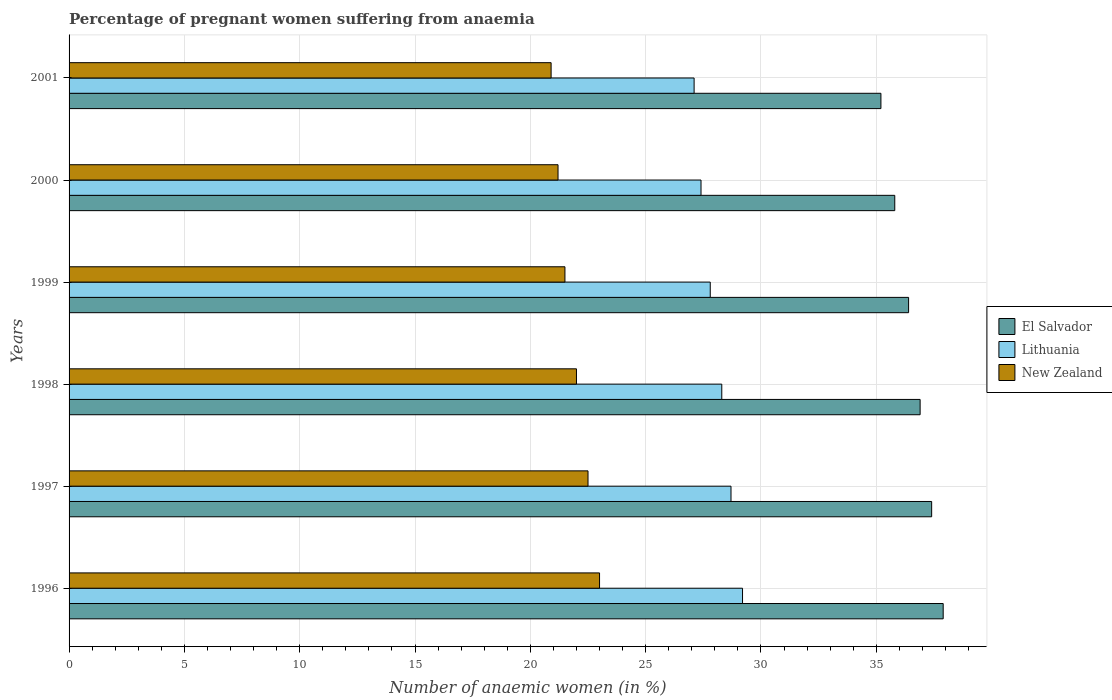How many different coloured bars are there?
Make the answer very short. 3. How many groups of bars are there?
Offer a terse response. 6. How many bars are there on the 1st tick from the top?
Your response must be concise. 3. How many bars are there on the 5th tick from the bottom?
Give a very brief answer. 3. In how many cases, is the number of bars for a given year not equal to the number of legend labels?
Offer a terse response. 0. What is the number of anaemic women in El Salvador in 1998?
Offer a terse response. 36.9. Across all years, what is the maximum number of anaemic women in Lithuania?
Offer a terse response. 29.2. Across all years, what is the minimum number of anaemic women in Lithuania?
Provide a succinct answer. 27.1. In which year was the number of anaemic women in El Salvador minimum?
Ensure brevity in your answer.  2001. What is the total number of anaemic women in New Zealand in the graph?
Your answer should be very brief. 131.1. What is the difference between the number of anaemic women in Lithuania in 1996 and that in 2001?
Give a very brief answer. 2.1. What is the difference between the number of anaemic women in Lithuania in 1996 and the number of anaemic women in New Zealand in 2000?
Provide a succinct answer. 8. What is the average number of anaemic women in New Zealand per year?
Provide a succinct answer. 21.85. In the year 1998, what is the difference between the number of anaemic women in El Salvador and number of anaemic women in Lithuania?
Make the answer very short. 8.6. In how many years, is the number of anaemic women in El Salvador greater than 37 %?
Ensure brevity in your answer.  2. What is the ratio of the number of anaemic women in El Salvador in 1996 to that in 2001?
Provide a succinct answer. 1.08. What is the difference between the highest and the lowest number of anaemic women in New Zealand?
Your response must be concise. 2.1. Is the sum of the number of anaemic women in New Zealand in 2000 and 2001 greater than the maximum number of anaemic women in El Salvador across all years?
Offer a terse response. Yes. What does the 3rd bar from the top in 1999 represents?
Ensure brevity in your answer.  El Salvador. What does the 1st bar from the bottom in 2001 represents?
Your answer should be compact. El Salvador. How many bars are there?
Give a very brief answer. 18. Are all the bars in the graph horizontal?
Your response must be concise. Yes. Are the values on the major ticks of X-axis written in scientific E-notation?
Make the answer very short. No. Does the graph contain any zero values?
Your answer should be compact. No. Does the graph contain grids?
Offer a very short reply. Yes. How are the legend labels stacked?
Provide a short and direct response. Vertical. What is the title of the graph?
Provide a succinct answer. Percentage of pregnant women suffering from anaemia. What is the label or title of the X-axis?
Your answer should be very brief. Number of anaemic women (in %). What is the Number of anaemic women (in %) in El Salvador in 1996?
Provide a succinct answer. 37.9. What is the Number of anaemic women (in %) of Lithuania in 1996?
Keep it short and to the point. 29.2. What is the Number of anaemic women (in %) of El Salvador in 1997?
Ensure brevity in your answer.  37.4. What is the Number of anaemic women (in %) in Lithuania in 1997?
Ensure brevity in your answer.  28.7. What is the Number of anaemic women (in %) in El Salvador in 1998?
Your answer should be very brief. 36.9. What is the Number of anaemic women (in %) of Lithuania in 1998?
Keep it short and to the point. 28.3. What is the Number of anaemic women (in %) in El Salvador in 1999?
Make the answer very short. 36.4. What is the Number of anaemic women (in %) of Lithuania in 1999?
Keep it short and to the point. 27.8. What is the Number of anaemic women (in %) of El Salvador in 2000?
Keep it short and to the point. 35.8. What is the Number of anaemic women (in %) of Lithuania in 2000?
Give a very brief answer. 27.4. What is the Number of anaemic women (in %) of New Zealand in 2000?
Provide a short and direct response. 21.2. What is the Number of anaemic women (in %) of El Salvador in 2001?
Give a very brief answer. 35.2. What is the Number of anaemic women (in %) of Lithuania in 2001?
Offer a very short reply. 27.1. What is the Number of anaemic women (in %) in New Zealand in 2001?
Provide a short and direct response. 20.9. Across all years, what is the maximum Number of anaemic women (in %) in El Salvador?
Your answer should be compact. 37.9. Across all years, what is the maximum Number of anaemic women (in %) in Lithuania?
Your response must be concise. 29.2. Across all years, what is the maximum Number of anaemic women (in %) in New Zealand?
Provide a short and direct response. 23. Across all years, what is the minimum Number of anaemic women (in %) of El Salvador?
Give a very brief answer. 35.2. Across all years, what is the minimum Number of anaemic women (in %) in Lithuania?
Ensure brevity in your answer.  27.1. Across all years, what is the minimum Number of anaemic women (in %) of New Zealand?
Ensure brevity in your answer.  20.9. What is the total Number of anaemic women (in %) of El Salvador in the graph?
Keep it short and to the point. 219.6. What is the total Number of anaemic women (in %) in Lithuania in the graph?
Provide a succinct answer. 168.5. What is the total Number of anaemic women (in %) of New Zealand in the graph?
Keep it short and to the point. 131.1. What is the difference between the Number of anaemic women (in %) in Lithuania in 1996 and that in 1997?
Make the answer very short. 0.5. What is the difference between the Number of anaemic women (in %) in New Zealand in 1996 and that in 1997?
Keep it short and to the point. 0.5. What is the difference between the Number of anaemic women (in %) of Lithuania in 1996 and that in 1998?
Ensure brevity in your answer.  0.9. What is the difference between the Number of anaemic women (in %) in New Zealand in 1996 and that in 1998?
Make the answer very short. 1. What is the difference between the Number of anaemic women (in %) of New Zealand in 1996 and that in 1999?
Ensure brevity in your answer.  1.5. What is the difference between the Number of anaemic women (in %) in New Zealand in 1996 and that in 2000?
Offer a very short reply. 1.8. What is the difference between the Number of anaemic women (in %) of Lithuania in 1996 and that in 2001?
Your answer should be very brief. 2.1. What is the difference between the Number of anaemic women (in %) in New Zealand in 1996 and that in 2001?
Offer a very short reply. 2.1. What is the difference between the Number of anaemic women (in %) of El Salvador in 1997 and that in 1998?
Provide a short and direct response. 0.5. What is the difference between the Number of anaemic women (in %) of New Zealand in 1997 and that in 1998?
Ensure brevity in your answer.  0.5. What is the difference between the Number of anaemic women (in %) of El Salvador in 1997 and that in 1999?
Provide a succinct answer. 1. What is the difference between the Number of anaemic women (in %) in El Salvador in 1997 and that in 2000?
Your answer should be compact. 1.6. What is the difference between the Number of anaemic women (in %) in New Zealand in 1997 and that in 2000?
Make the answer very short. 1.3. What is the difference between the Number of anaemic women (in %) in Lithuania in 1997 and that in 2001?
Ensure brevity in your answer.  1.6. What is the difference between the Number of anaemic women (in %) in New Zealand in 1997 and that in 2001?
Your response must be concise. 1.6. What is the difference between the Number of anaemic women (in %) in El Salvador in 1998 and that in 2000?
Make the answer very short. 1.1. What is the difference between the Number of anaemic women (in %) of New Zealand in 1998 and that in 2001?
Your answer should be very brief. 1.1. What is the difference between the Number of anaemic women (in %) in El Salvador in 1999 and that in 2000?
Your answer should be very brief. 0.6. What is the difference between the Number of anaemic women (in %) in Lithuania in 1999 and that in 2000?
Your response must be concise. 0.4. What is the difference between the Number of anaemic women (in %) of El Salvador in 1999 and that in 2001?
Offer a very short reply. 1.2. What is the difference between the Number of anaemic women (in %) in Lithuania in 1999 and that in 2001?
Make the answer very short. 0.7. What is the difference between the Number of anaemic women (in %) of New Zealand in 1999 and that in 2001?
Your answer should be very brief. 0.6. What is the difference between the Number of anaemic women (in %) in El Salvador in 1996 and the Number of anaemic women (in %) in Lithuania in 1997?
Ensure brevity in your answer.  9.2. What is the difference between the Number of anaemic women (in %) of El Salvador in 1996 and the Number of anaemic women (in %) of New Zealand in 1997?
Provide a short and direct response. 15.4. What is the difference between the Number of anaemic women (in %) in El Salvador in 1996 and the Number of anaemic women (in %) in Lithuania in 1998?
Offer a very short reply. 9.6. What is the difference between the Number of anaemic women (in %) of Lithuania in 1996 and the Number of anaemic women (in %) of New Zealand in 1998?
Ensure brevity in your answer.  7.2. What is the difference between the Number of anaemic women (in %) in El Salvador in 1996 and the Number of anaemic women (in %) in New Zealand in 2000?
Make the answer very short. 16.7. What is the difference between the Number of anaemic women (in %) of El Salvador in 1996 and the Number of anaemic women (in %) of Lithuania in 2001?
Your response must be concise. 10.8. What is the difference between the Number of anaemic women (in %) in Lithuania in 1996 and the Number of anaemic women (in %) in New Zealand in 2001?
Offer a terse response. 8.3. What is the difference between the Number of anaemic women (in %) in El Salvador in 1997 and the Number of anaemic women (in %) in New Zealand in 1999?
Your response must be concise. 15.9. What is the difference between the Number of anaemic women (in %) in Lithuania in 1997 and the Number of anaemic women (in %) in New Zealand in 2000?
Provide a short and direct response. 7.5. What is the difference between the Number of anaemic women (in %) in El Salvador in 1997 and the Number of anaemic women (in %) in Lithuania in 2001?
Make the answer very short. 10.3. What is the difference between the Number of anaemic women (in %) in El Salvador in 1997 and the Number of anaemic women (in %) in New Zealand in 2001?
Your answer should be compact. 16.5. What is the difference between the Number of anaemic women (in %) in El Salvador in 1998 and the Number of anaemic women (in %) in Lithuania in 2000?
Your answer should be very brief. 9.5. What is the difference between the Number of anaemic women (in %) in El Salvador in 1998 and the Number of anaemic women (in %) in New Zealand in 2000?
Give a very brief answer. 15.7. What is the difference between the Number of anaemic women (in %) in Lithuania in 1998 and the Number of anaemic women (in %) in New Zealand in 2000?
Provide a succinct answer. 7.1. What is the difference between the Number of anaemic women (in %) in Lithuania in 1999 and the Number of anaemic women (in %) in New Zealand in 2000?
Your response must be concise. 6.6. What is the difference between the Number of anaemic women (in %) in El Salvador in 1999 and the Number of anaemic women (in %) in New Zealand in 2001?
Provide a short and direct response. 15.5. What is the difference between the Number of anaemic women (in %) in El Salvador in 2000 and the Number of anaemic women (in %) in Lithuania in 2001?
Give a very brief answer. 8.7. What is the average Number of anaemic women (in %) of El Salvador per year?
Your response must be concise. 36.6. What is the average Number of anaemic women (in %) in Lithuania per year?
Your answer should be compact. 28.08. What is the average Number of anaemic women (in %) of New Zealand per year?
Make the answer very short. 21.85. In the year 1996, what is the difference between the Number of anaemic women (in %) of El Salvador and Number of anaemic women (in %) of New Zealand?
Ensure brevity in your answer.  14.9. In the year 1996, what is the difference between the Number of anaemic women (in %) of Lithuania and Number of anaemic women (in %) of New Zealand?
Provide a short and direct response. 6.2. In the year 1997, what is the difference between the Number of anaemic women (in %) in El Salvador and Number of anaemic women (in %) in Lithuania?
Ensure brevity in your answer.  8.7. In the year 1998, what is the difference between the Number of anaemic women (in %) in El Salvador and Number of anaemic women (in %) in New Zealand?
Provide a succinct answer. 14.9. In the year 1998, what is the difference between the Number of anaemic women (in %) of Lithuania and Number of anaemic women (in %) of New Zealand?
Your response must be concise. 6.3. In the year 1999, what is the difference between the Number of anaemic women (in %) in El Salvador and Number of anaemic women (in %) in Lithuania?
Your answer should be compact. 8.6. In the year 2001, what is the difference between the Number of anaemic women (in %) of El Salvador and Number of anaemic women (in %) of New Zealand?
Offer a very short reply. 14.3. In the year 2001, what is the difference between the Number of anaemic women (in %) of Lithuania and Number of anaemic women (in %) of New Zealand?
Your answer should be compact. 6.2. What is the ratio of the Number of anaemic women (in %) of El Salvador in 1996 to that in 1997?
Ensure brevity in your answer.  1.01. What is the ratio of the Number of anaemic women (in %) of Lithuania in 1996 to that in 1997?
Your answer should be very brief. 1.02. What is the ratio of the Number of anaemic women (in %) in New Zealand in 1996 to that in 1997?
Offer a terse response. 1.02. What is the ratio of the Number of anaemic women (in %) of El Salvador in 1996 to that in 1998?
Make the answer very short. 1.03. What is the ratio of the Number of anaemic women (in %) of Lithuania in 1996 to that in 1998?
Give a very brief answer. 1.03. What is the ratio of the Number of anaemic women (in %) in New Zealand in 1996 to that in 1998?
Ensure brevity in your answer.  1.05. What is the ratio of the Number of anaemic women (in %) in El Salvador in 1996 to that in 1999?
Your response must be concise. 1.04. What is the ratio of the Number of anaemic women (in %) of Lithuania in 1996 to that in 1999?
Give a very brief answer. 1.05. What is the ratio of the Number of anaemic women (in %) in New Zealand in 1996 to that in 1999?
Ensure brevity in your answer.  1.07. What is the ratio of the Number of anaemic women (in %) in El Salvador in 1996 to that in 2000?
Make the answer very short. 1.06. What is the ratio of the Number of anaemic women (in %) in Lithuania in 1996 to that in 2000?
Keep it short and to the point. 1.07. What is the ratio of the Number of anaemic women (in %) in New Zealand in 1996 to that in 2000?
Your response must be concise. 1.08. What is the ratio of the Number of anaemic women (in %) in El Salvador in 1996 to that in 2001?
Offer a very short reply. 1.08. What is the ratio of the Number of anaemic women (in %) in Lithuania in 1996 to that in 2001?
Offer a very short reply. 1.08. What is the ratio of the Number of anaemic women (in %) of New Zealand in 1996 to that in 2001?
Your response must be concise. 1.1. What is the ratio of the Number of anaemic women (in %) of El Salvador in 1997 to that in 1998?
Make the answer very short. 1.01. What is the ratio of the Number of anaemic women (in %) of Lithuania in 1997 to that in 1998?
Your answer should be very brief. 1.01. What is the ratio of the Number of anaemic women (in %) in New Zealand in 1997 to that in 1998?
Offer a terse response. 1.02. What is the ratio of the Number of anaemic women (in %) in El Salvador in 1997 to that in 1999?
Give a very brief answer. 1.03. What is the ratio of the Number of anaemic women (in %) of Lithuania in 1997 to that in 1999?
Keep it short and to the point. 1.03. What is the ratio of the Number of anaemic women (in %) in New Zealand in 1997 to that in 1999?
Provide a short and direct response. 1.05. What is the ratio of the Number of anaemic women (in %) in El Salvador in 1997 to that in 2000?
Ensure brevity in your answer.  1.04. What is the ratio of the Number of anaemic women (in %) of Lithuania in 1997 to that in 2000?
Keep it short and to the point. 1.05. What is the ratio of the Number of anaemic women (in %) of New Zealand in 1997 to that in 2000?
Provide a succinct answer. 1.06. What is the ratio of the Number of anaemic women (in %) of El Salvador in 1997 to that in 2001?
Ensure brevity in your answer.  1.06. What is the ratio of the Number of anaemic women (in %) in Lithuania in 1997 to that in 2001?
Provide a succinct answer. 1.06. What is the ratio of the Number of anaemic women (in %) of New Zealand in 1997 to that in 2001?
Your answer should be compact. 1.08. What is the ratio of the Number of anaemic women (in %) of El Salvador in 1998 to that in 1999?
Your response must be concise. 1.01. What is the ratio of the Number of anaemic women (in %) in New Zealand in 1998 to that in 1999?
Offer a very short reply. 1.02. What is the ratio of the Number of anaemic women (in %) in El Salvador in 1998 to that in 2000?
Your response must be concise. 1.03. What is the ratio of the Number of anaemic women (in %) of Lithuania in 1998 to that in 2000?
Give a very brief answer. 1.03. What is the ratio of the Number of anaemic women (in %) of New Zealand in 1998 to that in 2000?
Your response must be concise. 1.04. What is the ratio of the Number of anaemic women (in %) in El Salvador in 1998 to that in 2001?
Your response must be concise. 1.05. What is the ratio of the Number of anaemic women (in %) in Lithuania in 1998 to that in 2001?
Offer a terse response. 1.04. What is the ratio of the Number of anaemic women (in %) of New Zealand in 1998 to that in 2001?
Offer a very short reply. 1.05. What is the ratio of the Number of anaemic women (in %) in El Salvador in 1999 to that in 2000?
Make the answer very short. 1.02. What is the ratio of the Number of anaemic women (in %) of Lithuania in 1999 to that in 2000?
Ensure brevity in your answer.  1.01. What is the ratio of the Number of anaemic women (in %) of New Zealand in 1999 to that in 2000?
Make the answer very short. 1.01. What is the ratio of the Number of anaemic women (in %) in El Salvador in 1999 to that in 2001?
Give a very brief answer. 1.03. What is the ratio of the Number of anaemic women (in %) in Lithuania in 1999 to that in 2001?
Provide a short and direct response. 1.03. What is the ratio of the Number of anaemic women (in %) in New Zealand in 1999 to that in 2001?
Your answer should be compact. 1.03. What is the ratio of the Number of anaemic women (in %) in Lithuania in 2000 to that in 2001?
Keep it short and to the point. 1.01. What is the ratio of the Number of anaemic women (in %) in New Zealand in 2000 to that in 2001?
Your answer should be compact. 1.01. What is the difference between the highest and the second highest Number of anaemic women (in %) in El Salvador?
Make the answer very short. 0.5. What is the difference between the highest and the second highest Number of anaemic women (in %) in Lithuania?
Your response must be concise. 0.5. 